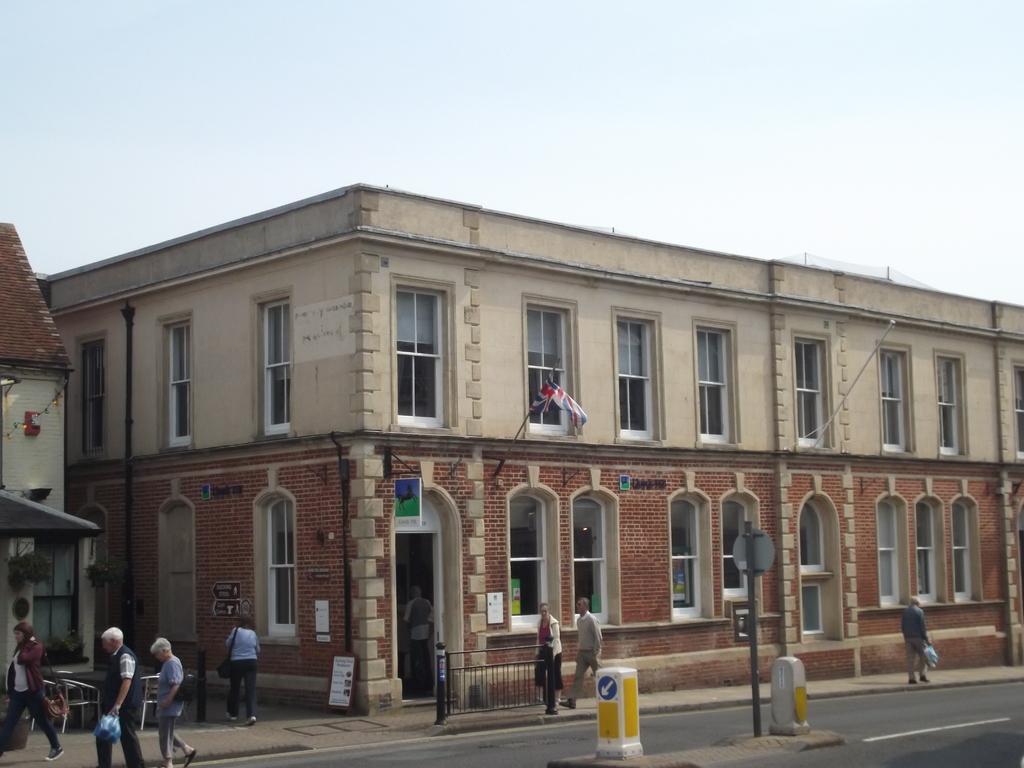Describe this image in one or two sentences. In this image we can see buildings, people walking on the road, barrier poles, sign boards, flag with flag post, pipelines and sky in the background. 